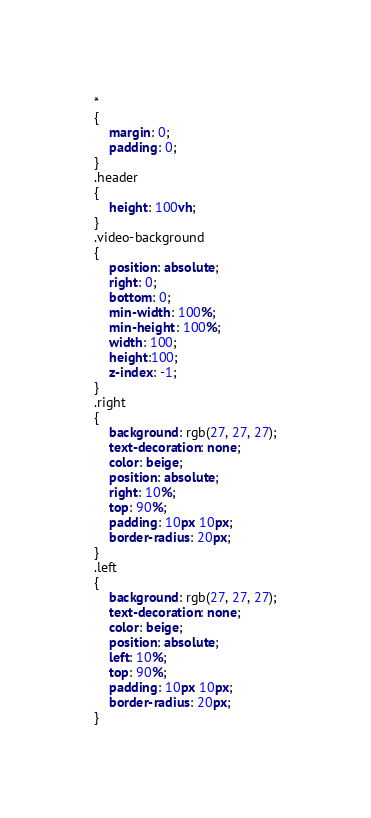<code> <loc_0><loc_0><loc_500><loc_500><_CSS_>*
{
    margin: 0;
    padding: 0;
}
.header
{
    height: 100vh;
}
.video-background
{
    position: absolute;
    right: 0;
    bottom: 0;
    min-width: 100%;
    min-height: 100%;
    width: 100;
    height:100;
    z-index: -1;
}
.right
{
    background: rgb(27, 27, 27);
    text-decoration: none;
    color: beige;
    position: absolute;
    right: 10%;
    top: 90%;
    padding: 10px 10px;
    border-radius: 20px;
}
.left
{
    background: rgb(27, 27, 27);
    text-decoration: none;
    color: beige;
    position: absolute;
    left: 10%;
    top: 90%;
    padding: 10px 10px;
    border-radius: 20px;
}</code> 